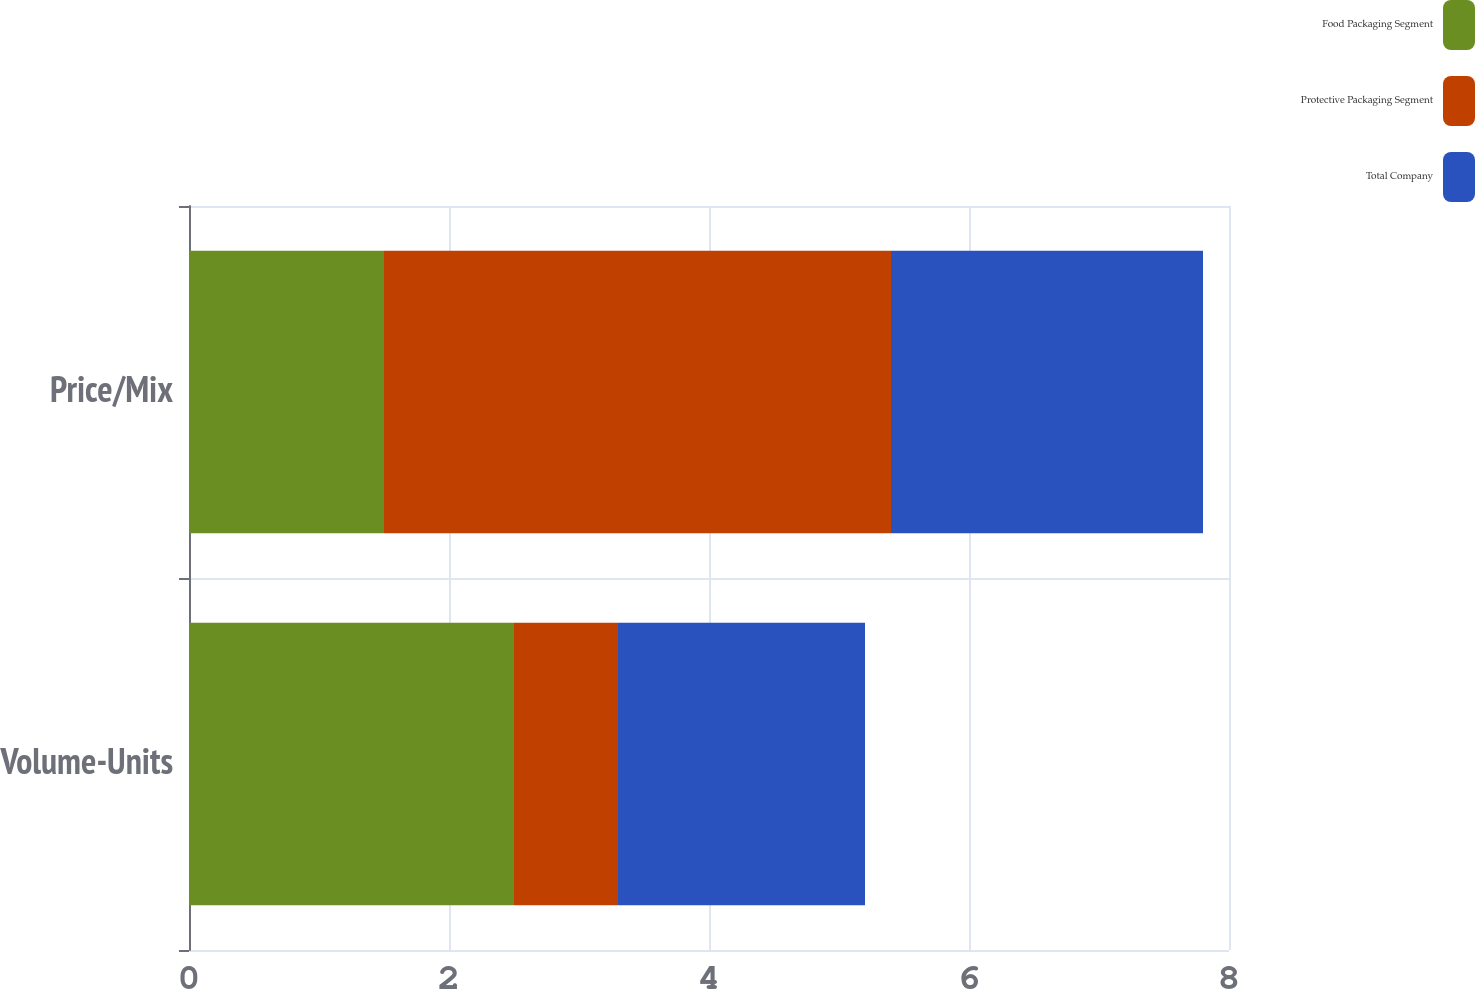Convert chart to OTSL. <chart><loc_0><loc_0><loc_500><loc_500><stacked_bar_chart><ecel><fcel>Volume-Units<fcel>Price/Mix<nl><fcel>Food Packaging Segment<fcel>2.5<fcel>1.5<nl><fcel>Protective Packaging Segment<fcel>0.8<fcel>3.9<nl><fcel>Total Company<fcel>1.9<fcel>2.4<nl></chart> 